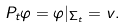<formula> <loc_0><loc_0><loc_500><loc_500>P _ { t } \varphi = \varphi | _ { \Sigma _ { t } } = v .</formula> 